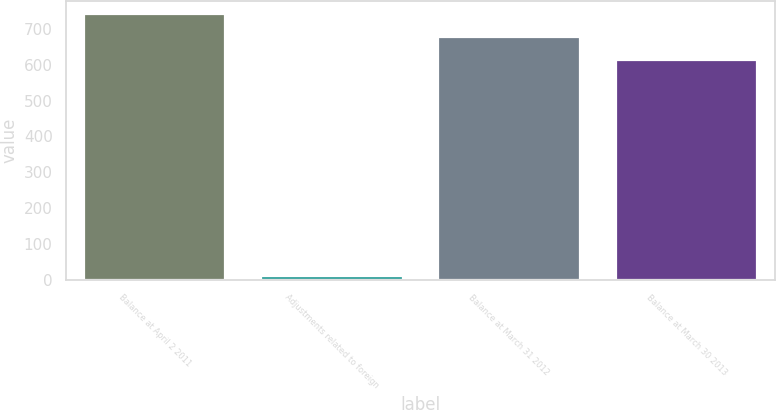Convert chart. <chart><loc_0><loc_0><loc_500><loc_500><bar_chart><fcel>Balance at April 2 2011<fcel>Adjustments related to foreign<fcel>Balance at March 31 2012<fcel>Balance at March 30 2013<nl><fcel>741.36<fcel>9.8<fcel>677.83<fcel>614.3<nl></chart> 